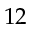Convert formula to latex. <formula><loc_0><loc_0><loc_500><loc_500>1 2</formula> 